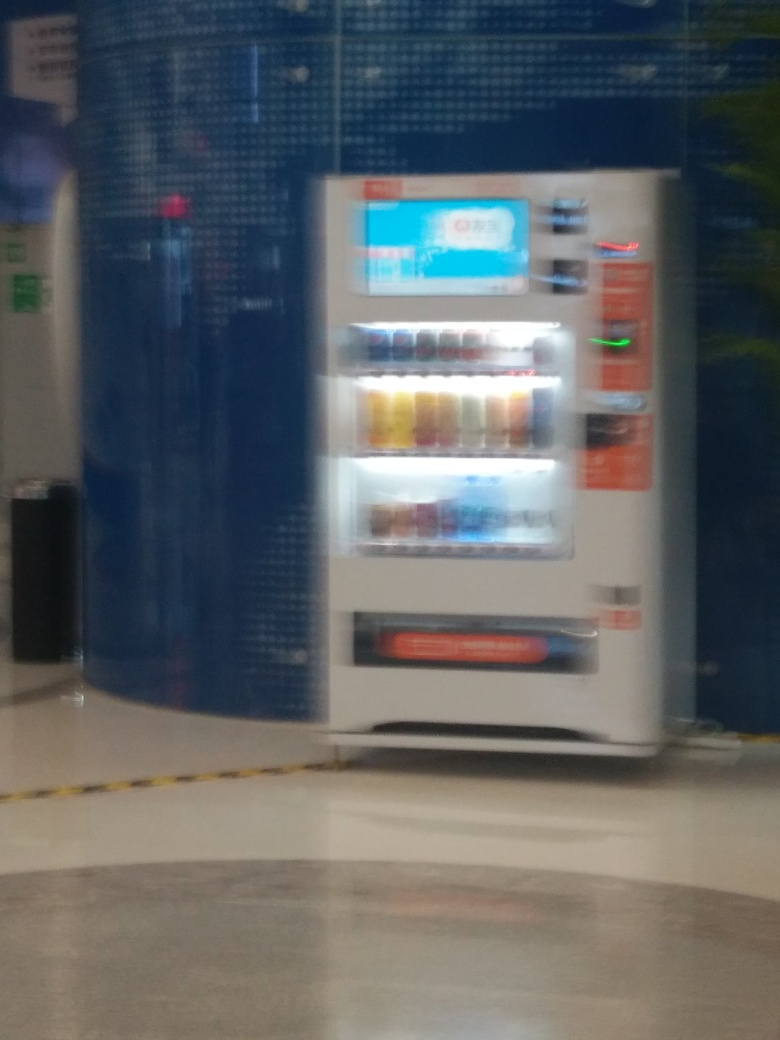Are there any lens flares? Upon reviewing the image, it appears that there are no lens flares present. The blurriness is due to the camera's focus rather than the artifact typically caused by bright light sources. 